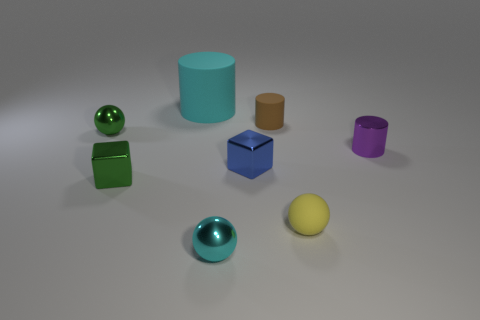What number of other objects are there of the same size as the cyan ball?
Your answer should be very brief. 6. There is a sphere to the right of the blue metal cube; what is it made of?
Keep it short and to the point. Rubber. The small rubber object on the left side of the tiny rubber object that is in front of the cylinder that is in front of the tiny green sphere is what shape?
Offer a terse response. Cylinder. Do the cyan rubber object and the brown cylinder have the same size?
Your answer should be compact. No. What number of things are green shiny objects or tiny shiny balls behind the tiny blue object?
Your answer should be compact. 2. What number of things are either cyan things in front of the tiny yellow sphere or green things behind the tiny purple metal object?
Your response must be concise. 2. There is a tiny green shiny cube; are there any yellow spheres right of it?
Make the answer very short. Yes. What color is the tiny cube that is right of the small shiny thing that is in front of the tiny green metal object in front of the purple thing?
Keep it short and to the point. Blue. Is the shape of the big rubber thing the same as the tiny brown rubber thing?
Your answer should be very brief. Yes. There is a cylinder that is the same material as the green block; what color is it?
Give a very brief answer. Purple. 